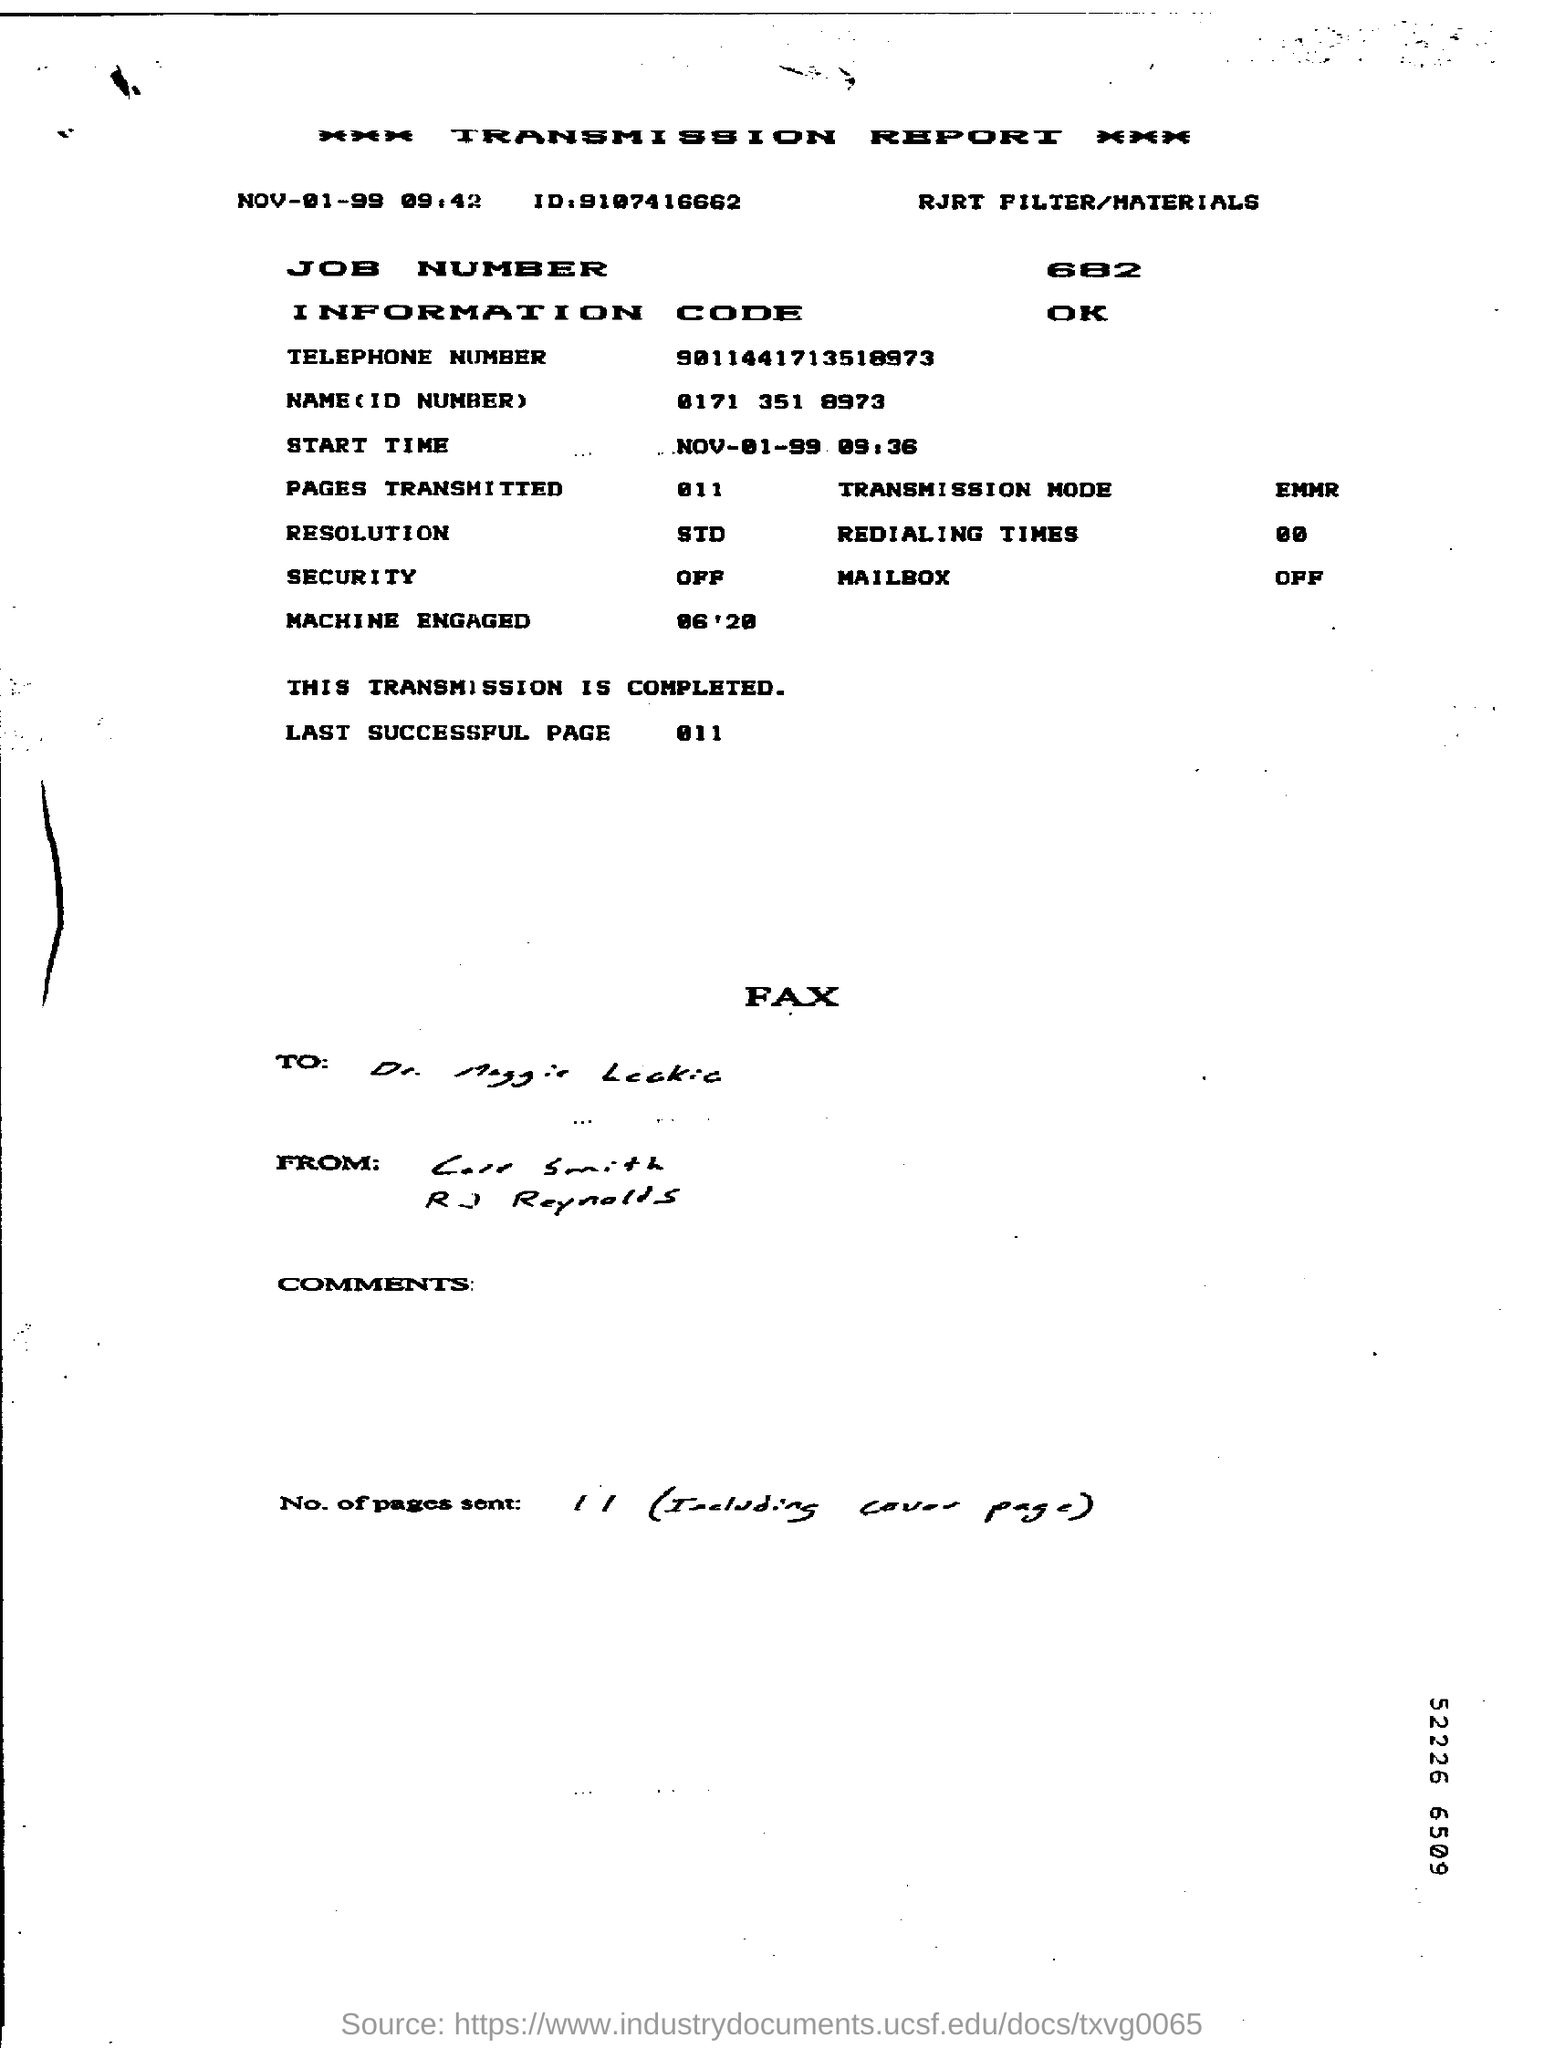List a handful of essential elements in this visual. The start time mentioned in the transmission report is November 1, 1999 at 9:36 a.m. The information code mentioned is: OK. The job number given is 682. The report mentions the transmission mode as EMMR. The telephone number provided in the report is 9011441713518973. 